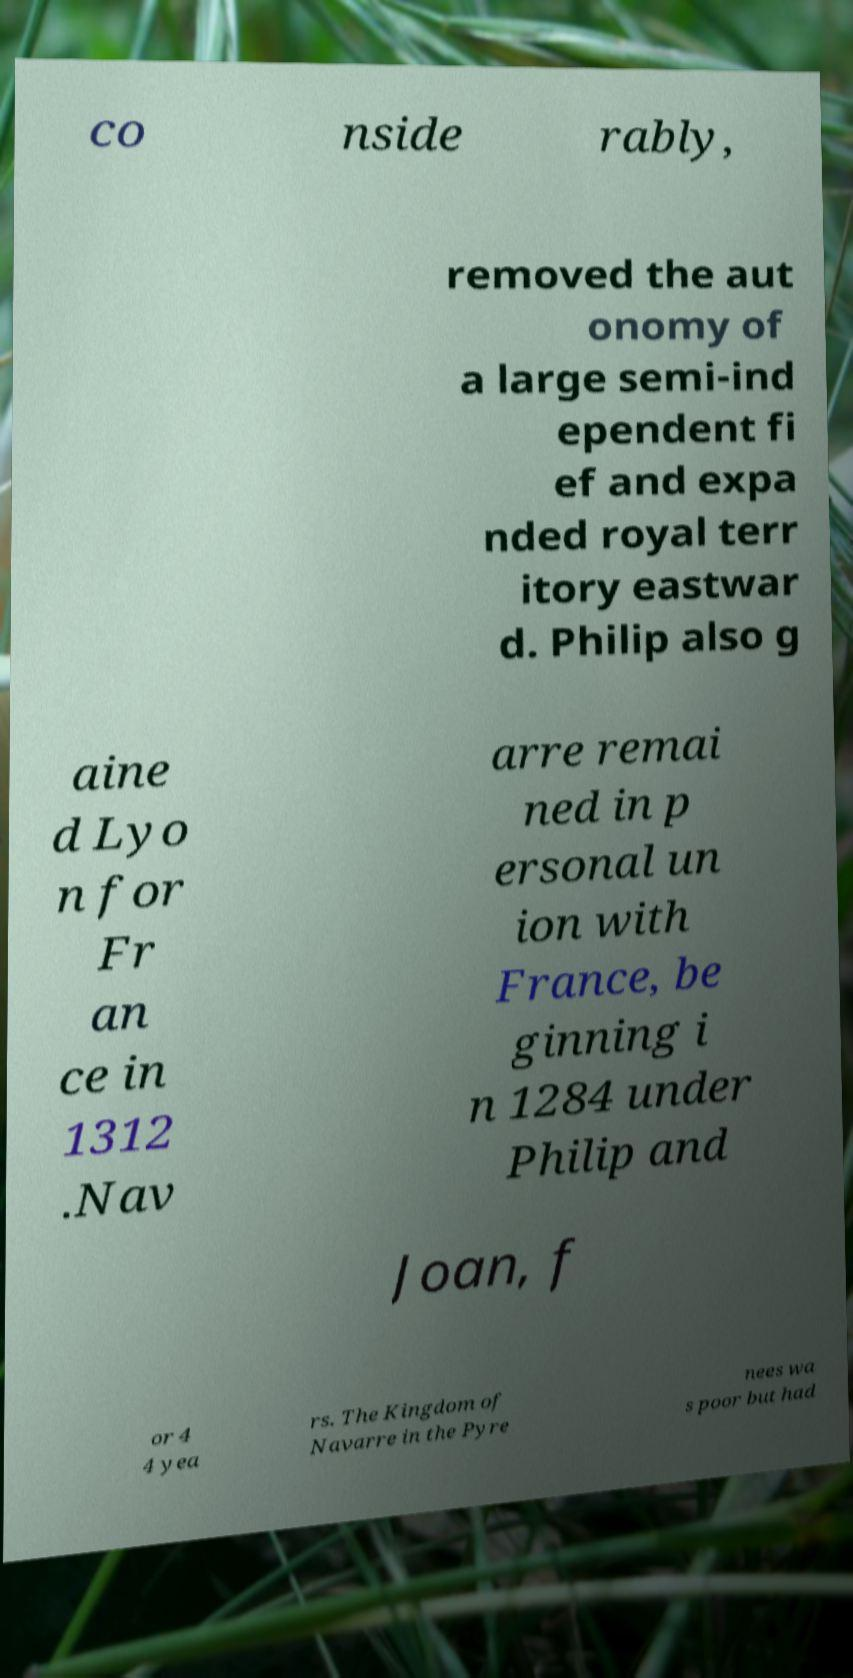Could you assist in decoding the text presented in this image and type it out clearly? co nside rably, removed the aut onomy of a large semi-ind ependent fi ef and expa nded royal terr itory eastwar d. Philip also g aine d Lyo n for Fr an ce in 1312 .Nav arre remai ned in p ersonal un ion with France, be ginning i n 1284 under Philip and Joan, f or 4 4 yea rs. The Kingdom of Navarre in the Pyre nees wa s poor but had 